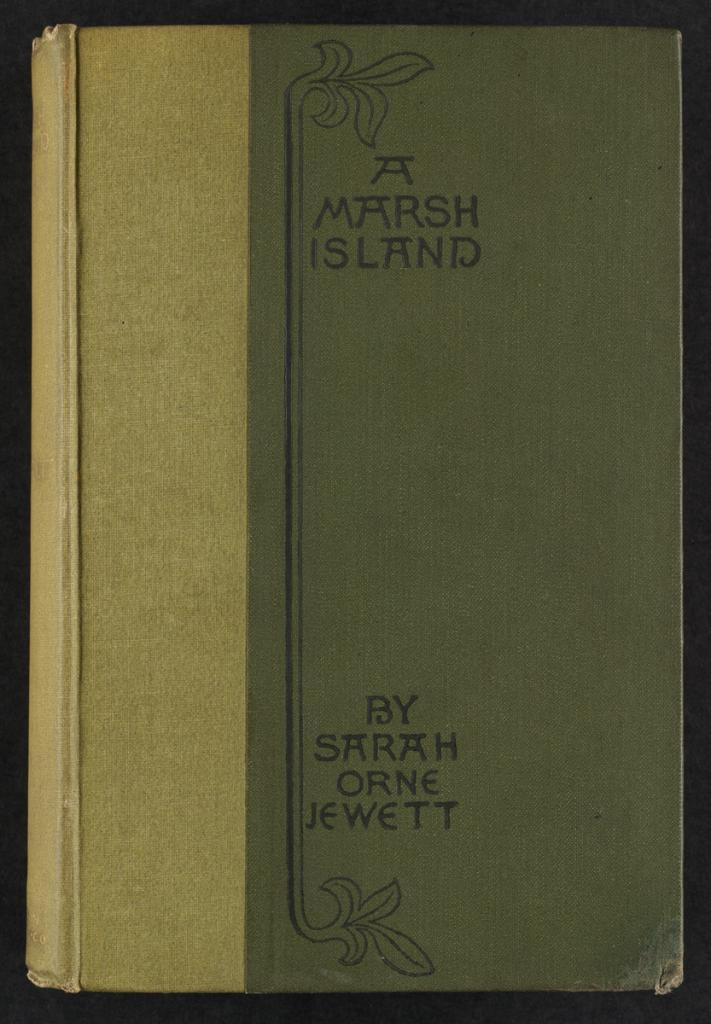<image>
Give a short and clear explanation of the subsequent image. a book called a marsh island by sarah orne jewett 